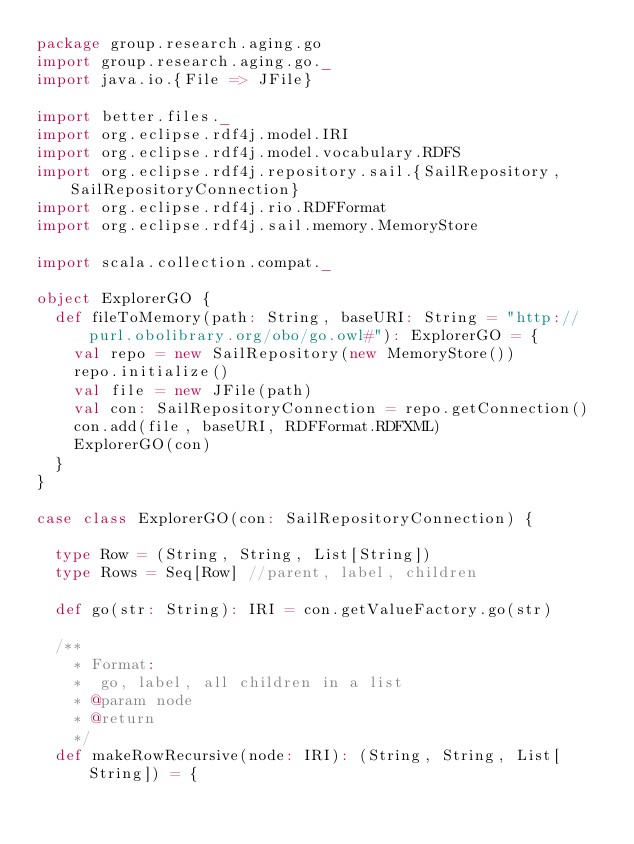<code> <loc_0><loc_0><loc_500><loc_500><_Scala_>package group.research.aging.go
import group.research.aging.go._
import java.io.{File => JFile}

import better.files._
import org.eclipse.rdf4j.model.IRI
import org.eclipse.rdf4j.model.vocabulary.RDFS
import org.eclipse.rdf4j.repository.sail.{SailRepository, SailRepositoryConnection}
import org.eclipse.rdf4j.rio.RDFFormat
import org.eclipse.rdf4j.sail.memory.MemoryStore

import scala.collection.compat._

object ExplorerGO {
  def fileToMemory(path: String, baseURI: String = "http://purl.obolibrary.org/obo/go.owl#"): ExplorerGO = {
    val repo = new SailRepository(new MemoryStore())
    repo.initialize()
    val file = new JFile(path)
    val con: SailRepositoryConnection = repo.getConnection()
    con.add(file, baseURI, RDFFormat.RDFXML)
    ExplorerGO(con)
  }
}

case class ExplorerGO(con: SailRepositoryConnection) {

  type Row = (String, String, List[String])
  type Rows = Seq[Row] //parent, label, children

  def go(str: String): IRI = con.getValueFactory.go(str)

  /**
    * Format:
    *  go, label, all children in a list
    * @param node
    * @return
    */
  def makeRowRecursive(node: IRI): (String, String, List[String]) = {</code> 